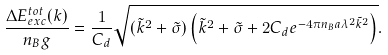<formula> <loc_0><loc_0><loc_500><loc_500>\frac { \Delta E _ { e x c } ^ { t o t } ( { k } ) } { n _ { B } g } & = \frac { 1 } { C _ { d } } \sqrt { ( \tilde { k } ^ { 2 } + \tilde { \sigma } ) \left ( \tilde { k } ^ { 2 } + \tilde { \sigma } + 2 C _ { d } e ^ { - 4 \pi n _ { B } a \lambda ^ { 2 } \tilde { k } ^ { 2 } } \right ) } .</formula> 